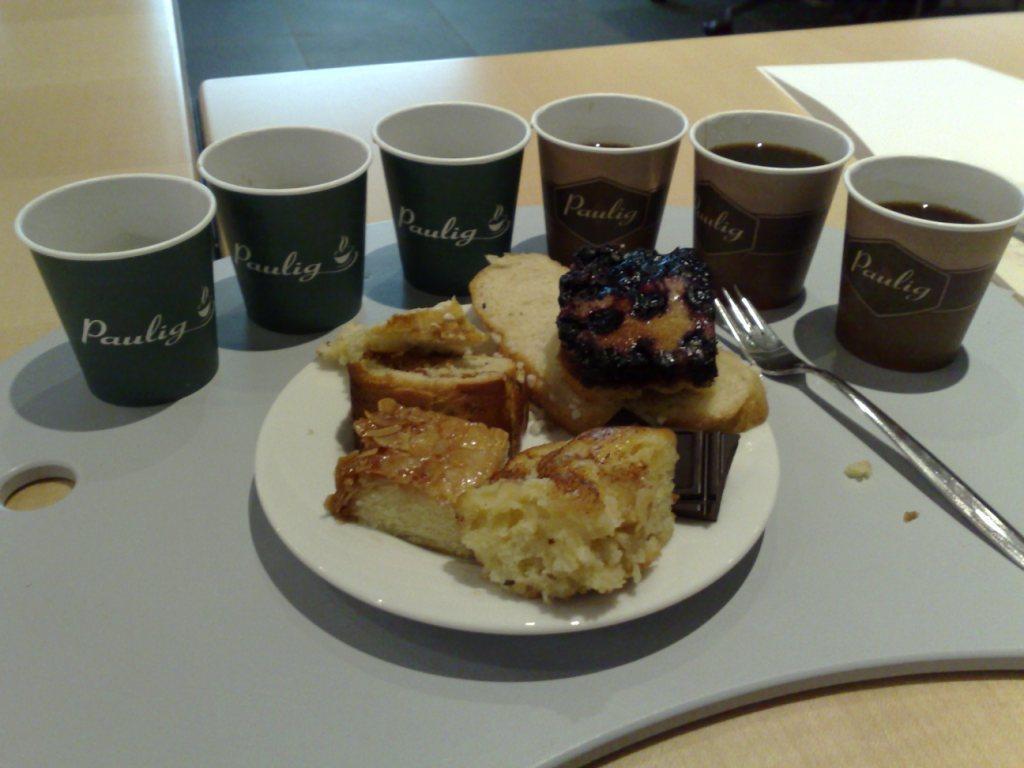Could you give a brief overview of what you see in this image? In this picture there is a plate in the center of the image, on a tray and, which contains bred and there are glasses around it and there is a fork and tissue on the right side of the image, which are placed on a table. 